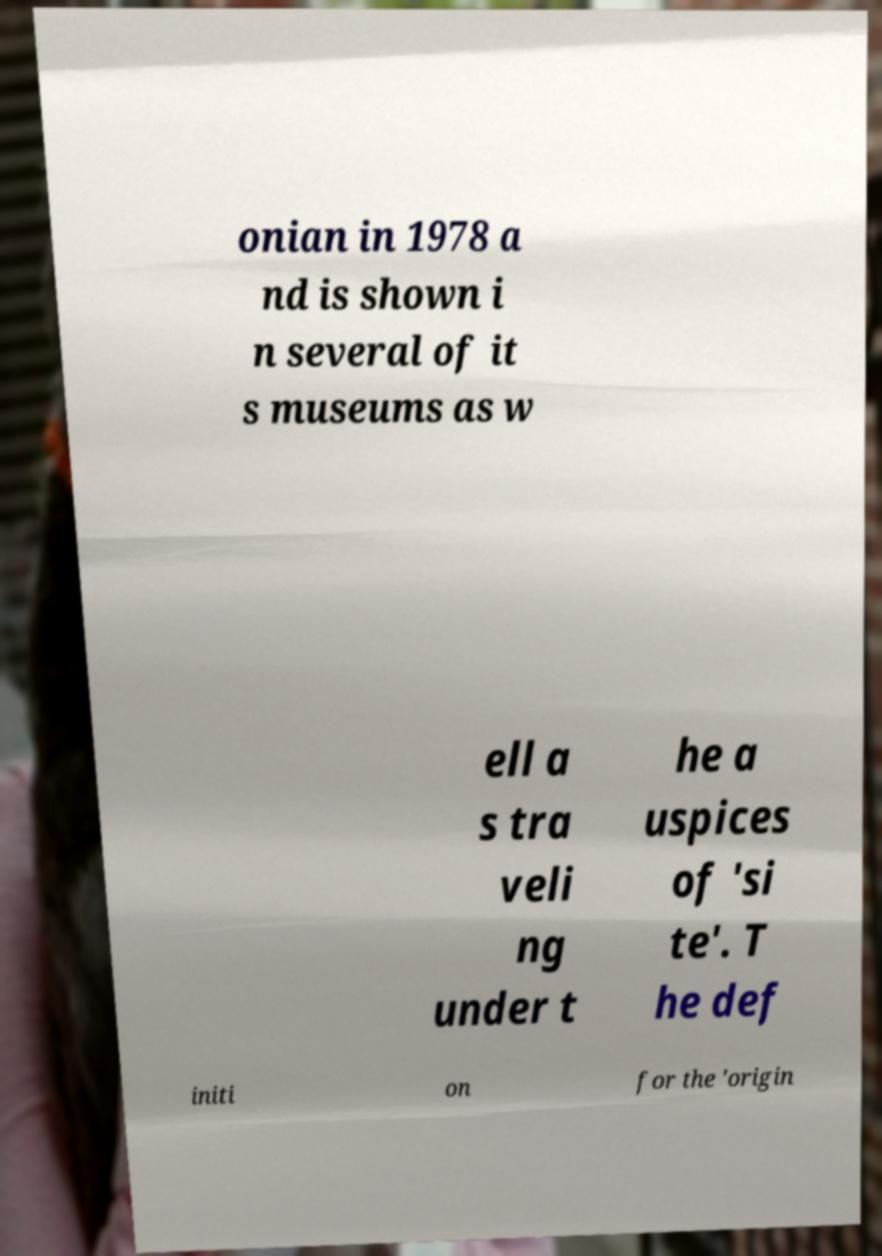Please identify and transcribe the text found in this image. onian in 1978 a nd is shown i n several of it s museums as w ell a s tra veli ng under t he a uspices of 'si te'. T he def initi on for the 'origin 